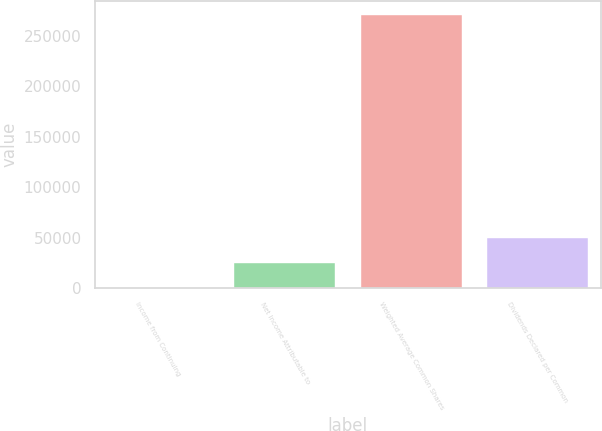<chart> <loc_0><loc_0><loc_500><loc_500><bar_chart><fcel>Income from Continuing<fcel>Net Income Attributable to<fcel>Weighted Average Common Shares<fcel>Dividends Declared per Common<nl><fcel>0.41<fcel>24727.1<fcel>270905<fcel>49453.7<nl></chart> 